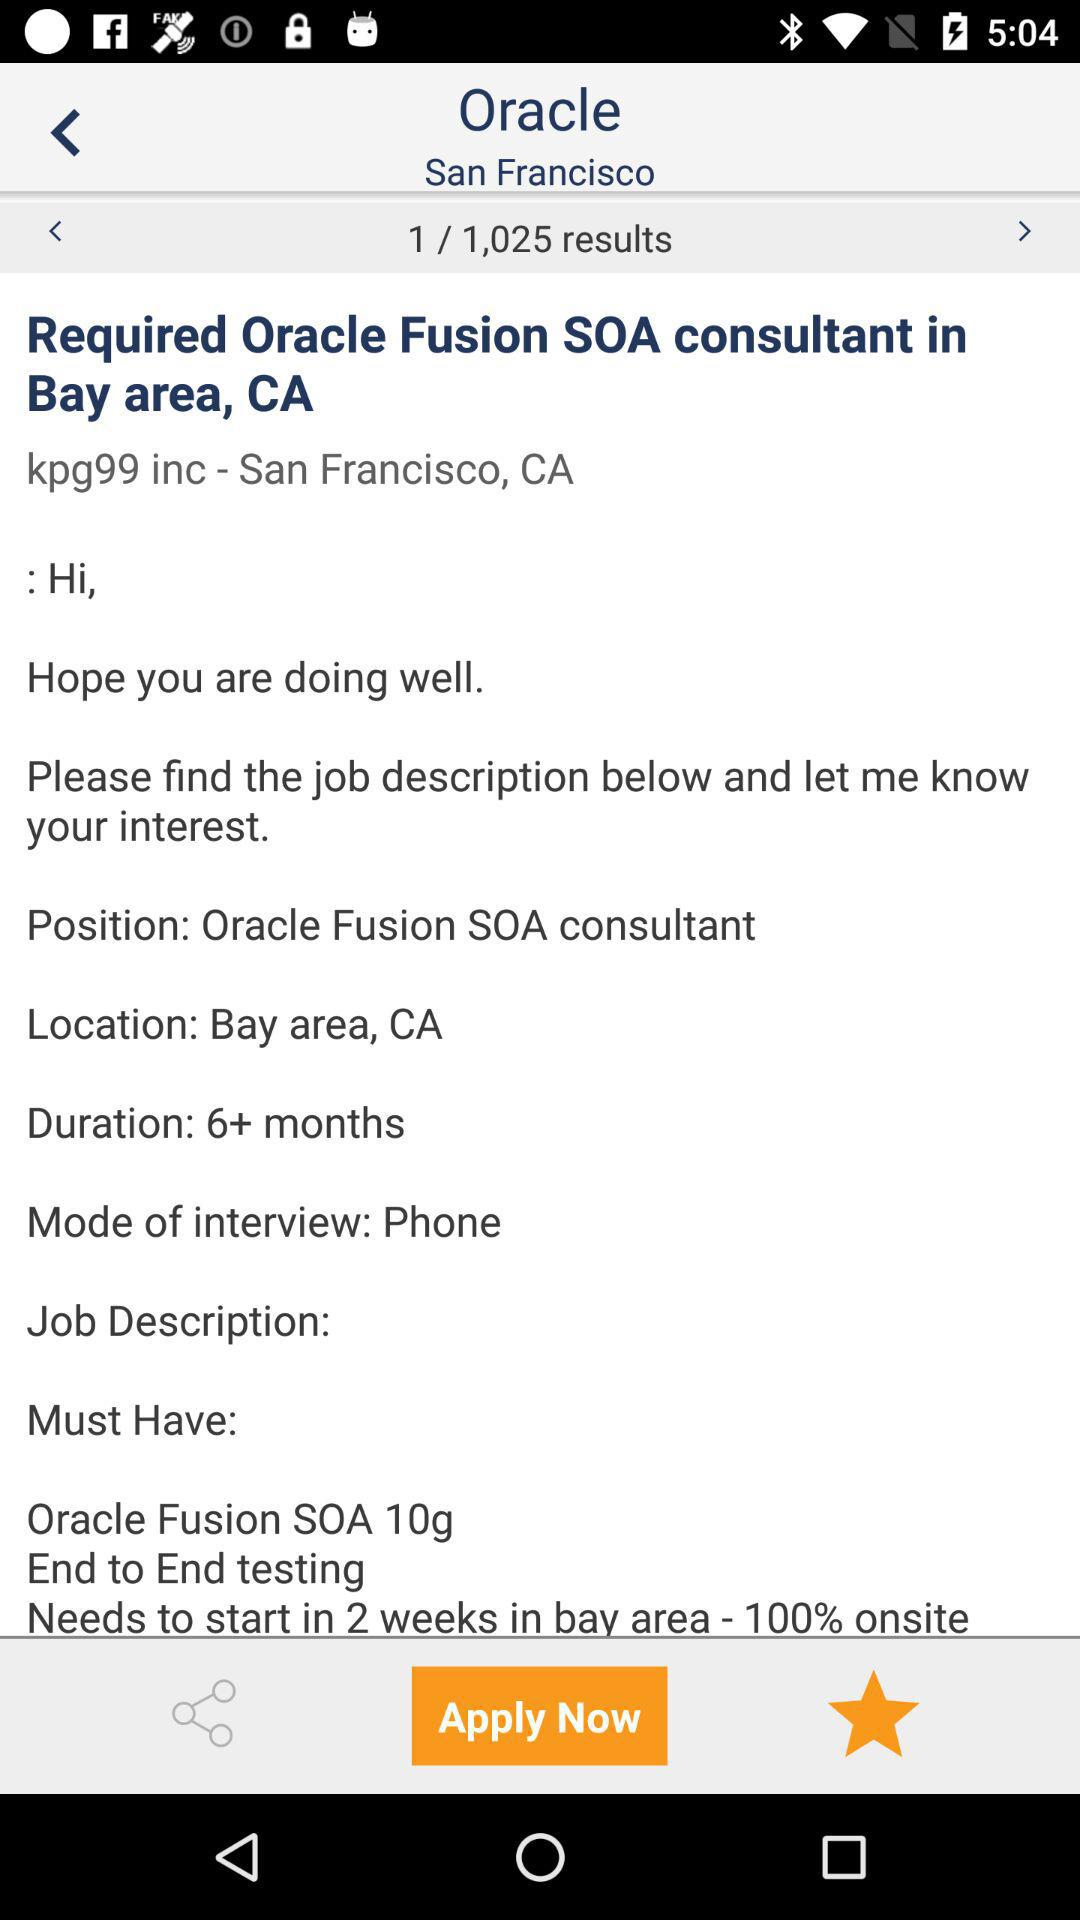Which result am I on? You are on the first result. 